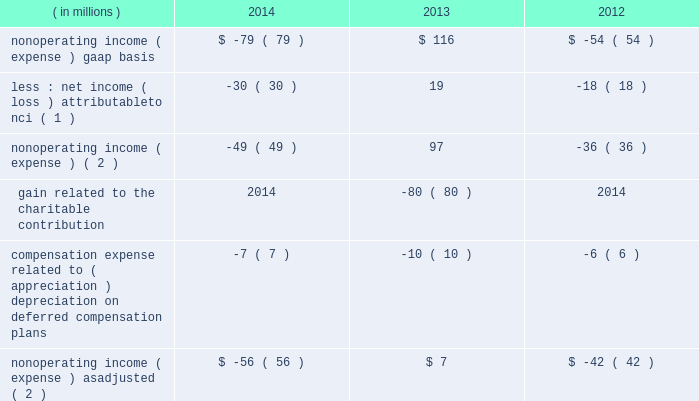Contribution incurred in 2013 and foreign currency remeasurement , partially offset by the $ 50 million reduction of an indemnification asset .
As adjusted .
Expense , as adjusted , increased $ 362 million , or 6% ( 6 % ) , to $ 6518 million in 2014 from $ 6156 million in 2013 .
The increase in total expense , as adjusted , is primarily attributable to higher employee compensation and benefits and direct fund expense .
Amounts related to the reduction of the indemnification asset and the charitable contribution have been excluded from as adjusted results .
2013 compared with 2012 gaap .
Expense increased $ 510 million , or 9% ( 9 % ) , from 2012 , primarily reflecting higher revenue-related expense and the $ 124 million expense related to the charitable contribution .
Employee compensation and benefits expense increased $ 273 million , or 8% ( 8 % ) , to $ 3560 million in 2013 from $ 3287 million in 2012 , reflecting higher headcount and higher incentive compensation driven by higher operating income , including higher performance fees .
Employees at december 31 , 2013 totaled approximately 11400 compared with approximately 10500 at december 31 , 2012 .
Distribution and servicing costs totaled $ 353 million in 2013 compared with $ 364 million in 2012 .
These costs included payments to bank of america/merrill lynch under a global distribution agreement and payments to pnc , as well as other third parties , primarily associated with the distribution and servicing of client investments in certain blackrock products .
Distribution and servicing costs for 2013 and 2012 included $ 184 million and $ 195 million , respectively , attributable to bank of america/merrill lynch .
Direct fund expense increased $ 66 million , reflecting higher average aum , primarily related to ishares , where blackrock pays certain nonadvisory expense of the funds .
General and administration expense increased $ 181 million , largely driven by the $ 124 million expense related to the charitable contribution , higher marketing and promotional costs and various lease exit costs .
The full year 2012 included a one-time $ 30 million contribution to stifs .
As adjusted .
Expense , as adjusted , increased $ 393 million , or 7% ( 7 % ) , to $ 6156 million in 2013 from $ 5763 million in 2012 .
The increase in total expense , as adjusted , is primarily attributable to higher employee compensation and benefits , direct fund expense and general and administration expense .
Nonoperating results nonoperating income ( expense ) , less net income ( loss ) attributable to nci for 2014 , 2013 and 2012 was as follows : ( in millions ) 2014 2013 2012 nonoperating income ( expense ) , gaap basis $ ( 79 ) $ 116 $ ( 54 ) less : net income ( loss ) attributable to nci ( 1 ) ( 30 ) 19 ( 18 ) nonoperating income ( expense ) ( 2 ) ( 49 ) 97 ( 36 ) gain related to the charitable contribution 2014 ( 80 ) 2014 compensation expense related to ( appreciation ) depreciation on deferred compensation plans ( 7 ) ( 10 ) ( 6 ) nonoperating income ( expense ) , as adjusted ( 2 ) $ ( 56 ) $ 7 $ ( 42 ) ( 1 ) amounts included losses of $ 41 million and $ 38 million attributable to consolidated variable interest entities ( 201cvies 201d ) for 2014 and 2012 , respectively .
During 2013 , the company did not record any nonoperating income ( loss ) or net income ( loss ) attributable to vies on the consolidated statements of income .
( 2 ) net of net income ( loss ) attributable to nci. .
Contribution incurred in 2013 and foreign currency remeasurement , partially offset by the $ 50 million reduction of an indemnification asset .
As adjusted .
Expense , as adjusted , increased $ 362 million , or 6% ( 6 % ) , to $ 6518 million in 2014 from $ 6156 million in 2013 .
The increase in total expense , as adjusted , is primarily attributable to higher employee compensation and benefits and direct fund expense .
Amounts related to the reduction of the indemnification asset and the charitable contribution have been excluded from as adjusted results .
2013 compared with 2012 gaap .
Expense increased $ 510 million , or 9% ( 9 % ) , from 2012 , primarily reflecting higher revenue-related expense and the $ 124 million expense related to the charitable contribution .
Employee compensation and benefits expense increased $ 273 million , or 8% ( 8 % ) , to $ 3560 million in 2013 from $ 3287 million in 2012 , reflecting higher headcount and higher incentive compensation driven by higher operating income , including higher performance fees .
Employees at december 31 , 2013 totaled approximately 11400 compared with approximately 10500 at december 31 , 2012 .
Distribution and servicing costs totaled $ 353 million in 2013 compared with $ 364 million in 2012 .
These costs included payments to bank of america/merrill lynch under a global distribution agreement and payments to pnc , as well as other third parties , primarily associated with the distribution and servicing of client investments in certain blackrock products .
Distribution and servicing costs for 2013 and 2012 included $ 184 million and $ 195 million , respectively , attributable to bank of america/merrill lynch .
Direct fund expense increased $ 66 million , reflecting higher average aum , primarily related to ishares , where blackrock pays certain nonadvisory expense of the funds .
General and administration expense increased $ 181 million , largely driven by the $ 124 million expense related to the charitable contribution , higher marketing and promotional costs and various lease exit costs .
The full year 2012 included a one-time $ 30 million contribution to stifs .
As adjusted .
Expense , as adjusted , increased $ 393 million , or 7% ( 7 % ) , to $ 6156 million in 2013 from $ 5763 million in 2012 .
The increase in total expense , as adjusted , is primarily attributable to higher employee compensation and benefits , direct fund expense and general and administration expense .
Nonoperating results nonoperating income ( expense ) , less net income ( loss ) attributable to nci for 2014 , 2013 and 2012 was as follows : ( in millions ) 2014 2013 2012 nonoperating income ( expense ) , gaap basis $ ( 79 ) $ 116 $ ( 54 ) less : net income ( loss ) attributable to nci ( 1 ) ( 30 ) 19 ( 18 ) nonoperating income ( expense ) ( 2 ) ( 49 ) 97 ( 36 ) gain related to the charitable contribution 2014 ( 80 ) 2014 compensation expense related to ( appreciation ) depreciation on deferred compensation plans ( 7 ) ( 10 ) ( 6 ) nonoperating income ( expense ) , as adjusted ( 2 ) $ ( 56 ) $ 7 $ ( 42 ) ( 1 ) amounts included losses of $ 41 million and $ 38 million attributable to consolidated variable interest entities ( 201cvies 201d ) for 2014 and 2012 , respectively .
During 2013 , the company did not record any nonoperating income ( loss ) or net income ( loss ) attributable to vies on the consolidated statements of income .
( 2 ) net of net income ( loss ) attributable to nci. .
What portion of the increase in general and administration expense is driven by charitable contributions? 
Computations: (124 / 181)
Answer: 0.68508. 